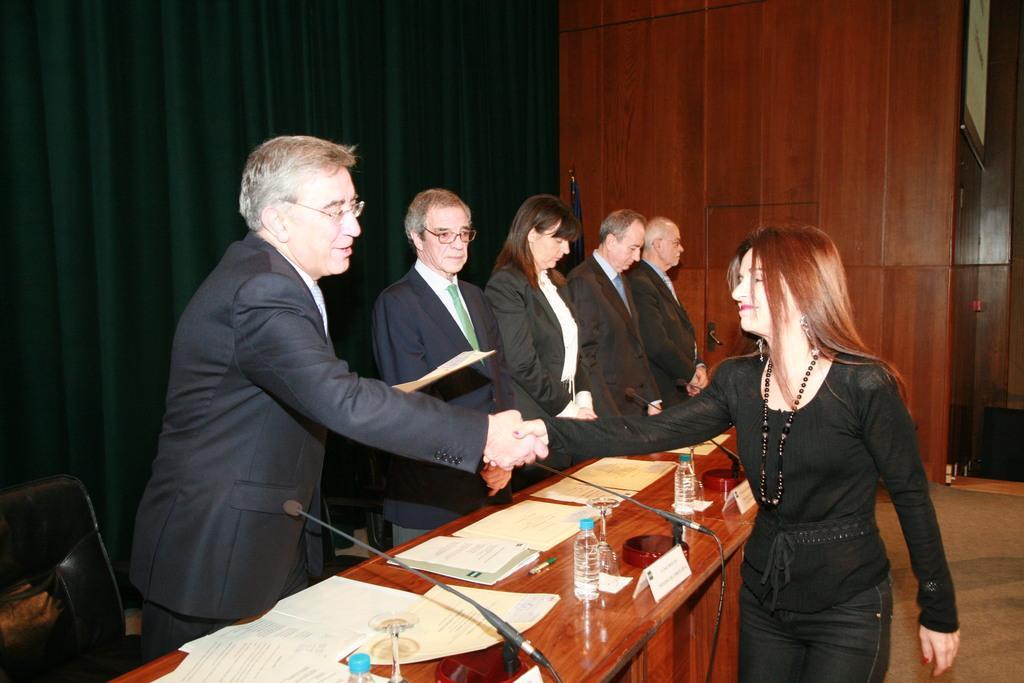Please provide a concise description of this image. Here we can see some persons are standing on the floor. This is table. On the table there are bottles, and papers. This is mike. And there is a chair. On the background there is a door and this is curtain. 